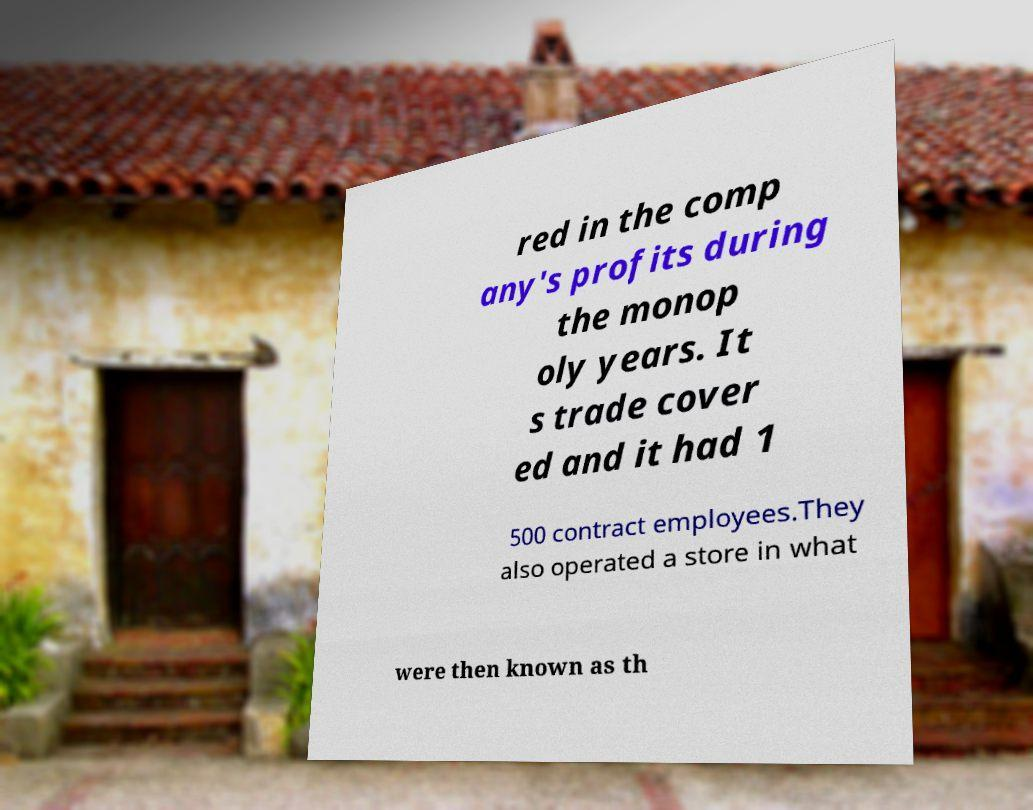Could you assist in decoding the text presented in this image and type it out clearly? red in the comp any's profits during the monop oly years. It s trade cover ed and it had 1 500 contract employees.They also operated a store in what were then known as th 